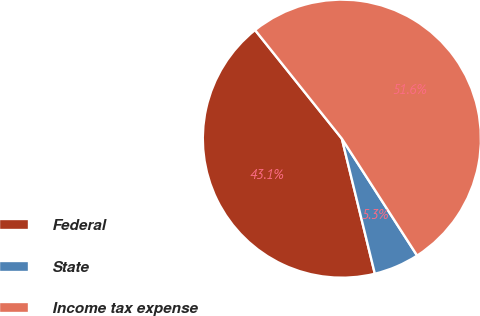Convert chart. <chart><loc_0><loc_0><loc_500><loc_500><pie_chart><fcel>Federal<fcel>State<fcel>Income tax expense<nl><fcel>43.08%<fcel>5.29%<fcel>51.63%<nl></chart> 